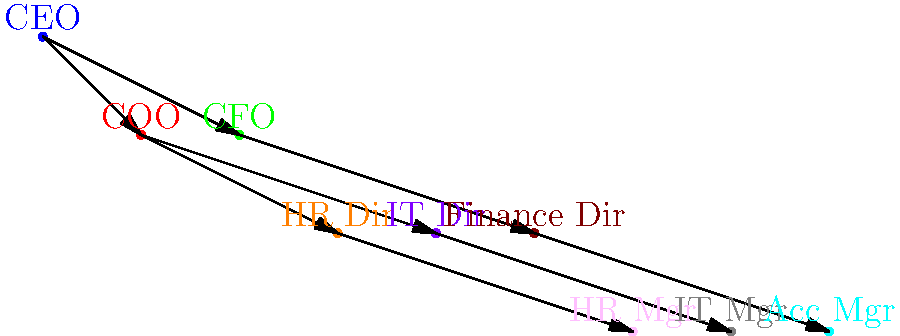In the organizational structure shown above, what is the total number of direct reports for positions at the second level of the hierarchy? To solve this question, we need to follow these steps:

1. Identify the levels in the organizational hierarchy:
   - Level 1 (top): CEO
   - Level 2: COO and CFO
   - Level 3: HR Director, IT Director, and Finance Director
   - Level 4 (bottom): HR Manager, IT Manager, and Accounting Manager

2. Focus on the second level, which includes COO and CFO.

3. Count the direct reports for each position at the second level:
   - COO has 2 direct reports: HR Director and IT Director
   - CFO has 1 direct report: Finance Director

4. Sum up the total number of direct reports:
   Total direct reports = COO's direct reports + CFO's direct reports
   Total direct reports = 2 + 1 = 3

Therefore, the total number of direct reports for positions at the second level of the hierarchy is 3.
Answer: 3 